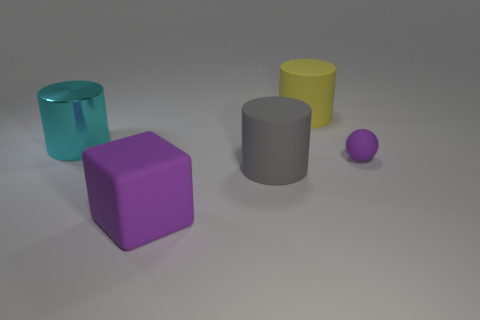Is there any other thing that is made of the same material as the big cyan thing?
Give a very brief answer. No. What color is the rubber cylinder behind the ball?
Keep it short and to the point. Yellow. Does the small matte thing have the same color as the matte object that is in front of the gray matte cylinder?
Your response must be concise. Yes. Is the number of big gray objects less than the number of cylinders?
Provide a short and direct response. Yes. Does the object right of the yellow object have the same color as the large block?
Offer a very short reply. Yes. What number of other purple blocks have the same size as the purple rubber cube?
Give a very brief answer. 0. Is there a small object of the same color as the rubber cube?
Your answer should be compact. Yes. Do the tiny thing and the big gray object have the same material?
Ensure brevity in your answer.  Yes. What number of big cyan things are the same shape as the large yellow object?
Offer a very short reply. 1. What shape is the purple thing that is made of the same material as the purple sphere?
Offer a terse response. Cube. 